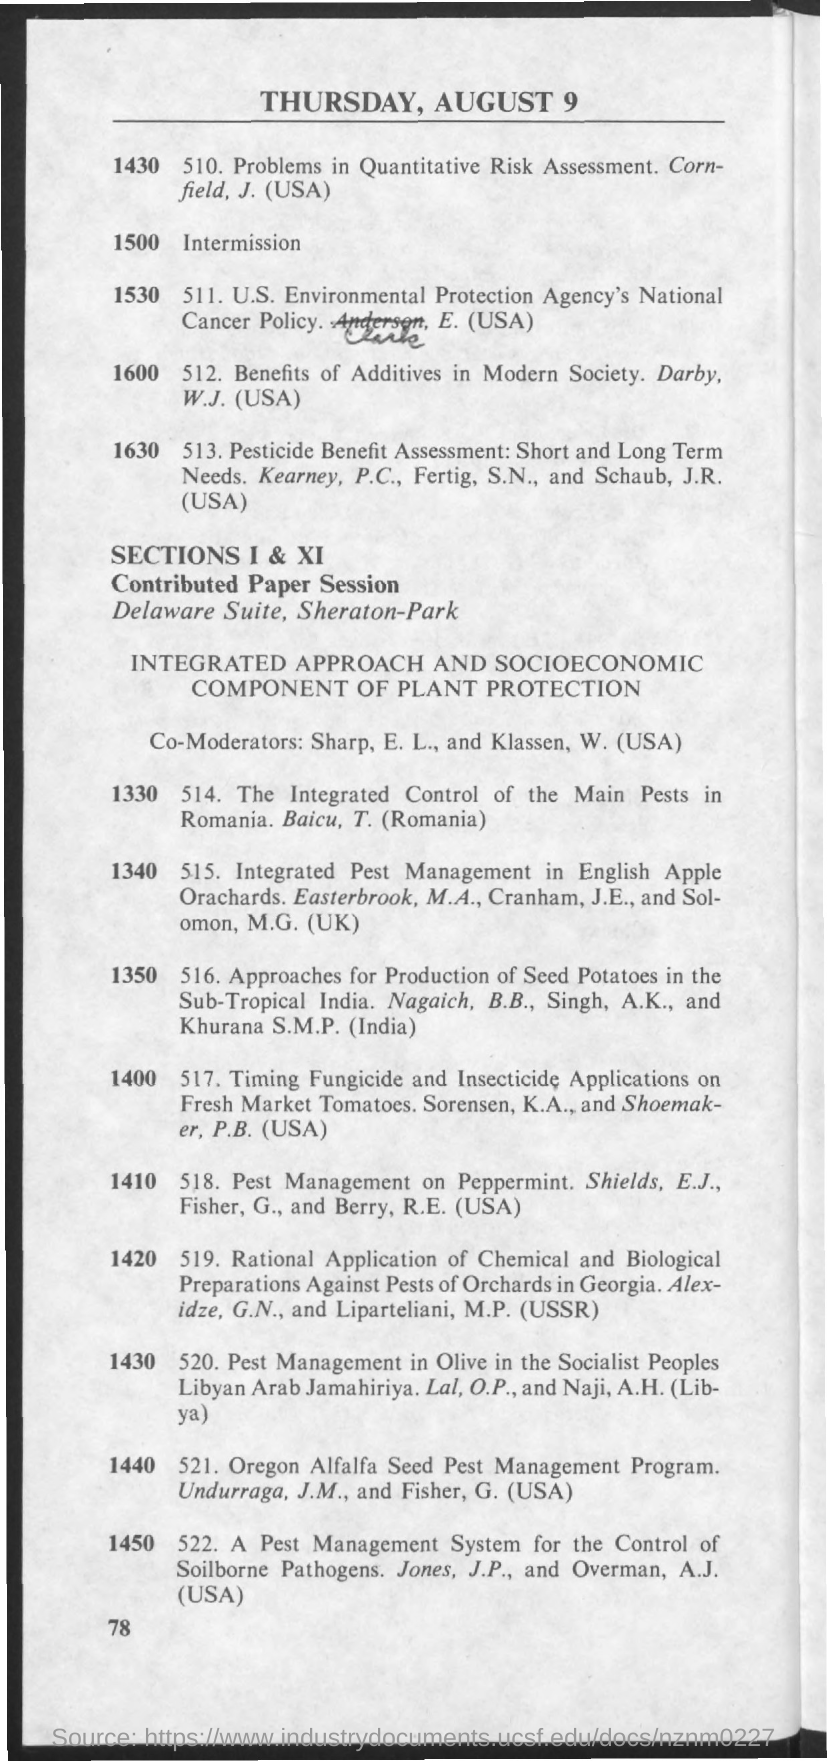What is the date mentioned in the document?
Provide a succinct answer. Thursday, august 9. Berry, R.E. is from which country?
Offer a terse response. Usa. Klassen, W. is from which country
Ensure brevity in your answer.  (usa). Khurana S.M.P is from which country?
Provide a succinct answer. (india). 